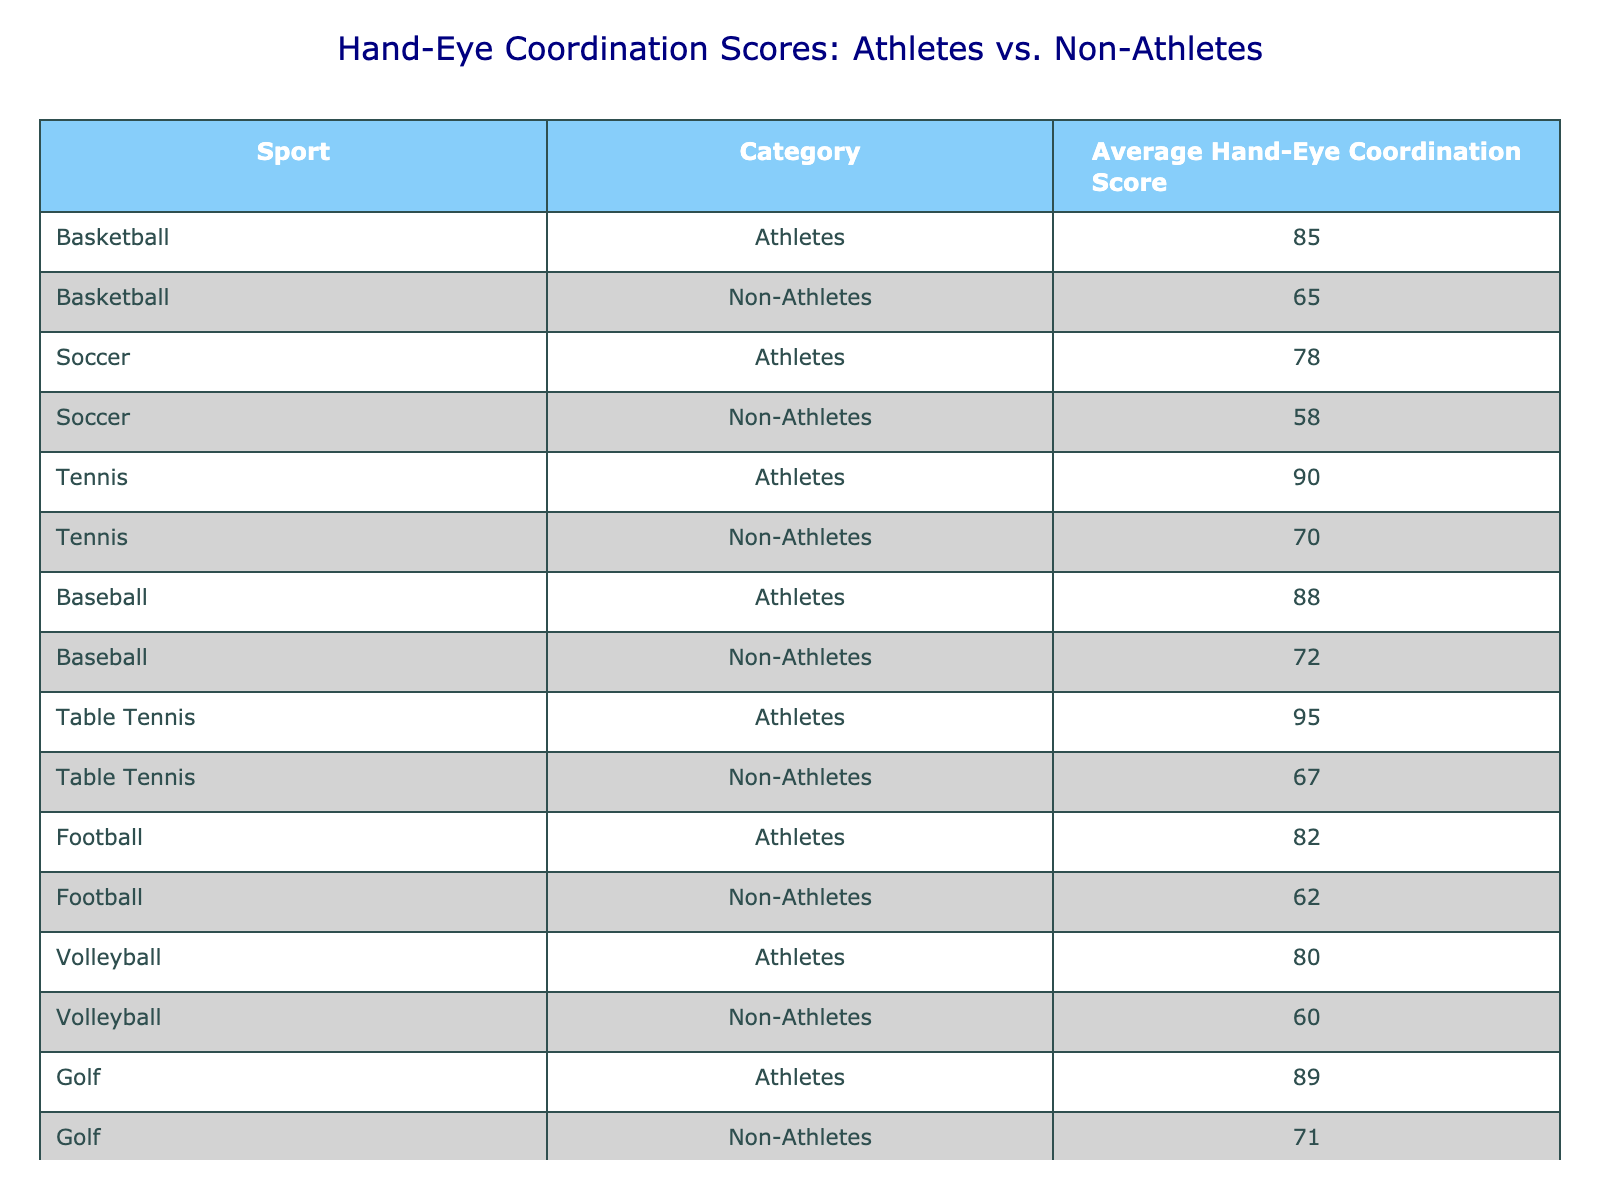What is the average hand-eye coordination score of athletes in tennis? The table shows that the average hand-eye coordination score for athletes in tennis is 90.
Answer: 90 What is the average hand-eye coordination score for non-athletes in basketball? According to the table, the average score for non-athletes in basketball is 65.
Answer: 65 Which sport has the highest average hand-eye coordination score for athletes? By examining the table, we see that table tennis has the highest score for athletes at 95.
Answer: 95 What is the difference in average hand-eye coordination scores between athletes and non-athletes in baseball? The average score for athletes in baseball is 88, and for non-athletes, it is 72. The difference is 88 - 72 = 16.
Answer: 16 Are athletes in soccer more coordinated than non-athletes based on the average scores? Yes, the average score for athletes in soccer is 78, while non-athletes have a score of 58, meaning athletes are more coordinated.
Answer: Yes What is the average hand-eye coordination score of non-athletes across all sports listed in the table? To calculate the average for non-athletes, we sum their scores: 65 + 58 + 70 + 72 + 67 + 62 + 60 + 71 + 57 = 582. There are 9 sports, so the average is 582 / 9 = 64.67.
Answer: 64.67 Is the average hand-eye coordination score for athletes in football higher than that of non-athletes in tennis? Yes, the average score for athletes in football is 82, which is higher than the non-athlete score in tennis (70).
Answer: Yes What is the total sum of average hand-eye coordination scores for athletes across all sports? The total for athletes is calculated as follows: 85 + 78 + 90 + 88 + 95 + 82 + 80 + 89 + 77 = 784.
Answer: 784 